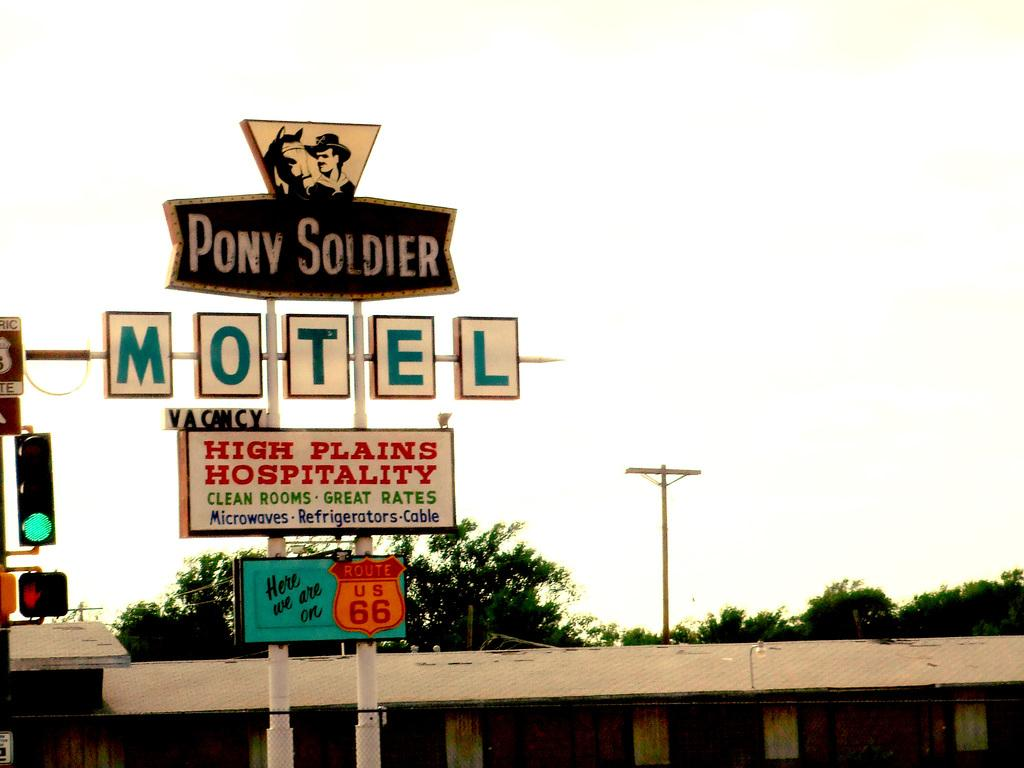<image>
Summarize the visual content of the image. Street sign with one that says "Pony Soldier" for an establishment. 